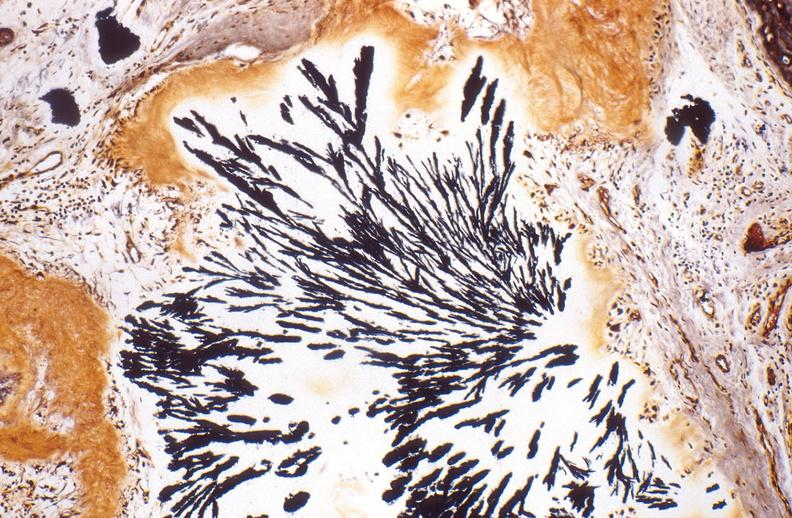what is present?
Answer the question using a single word or phrase. Joints 